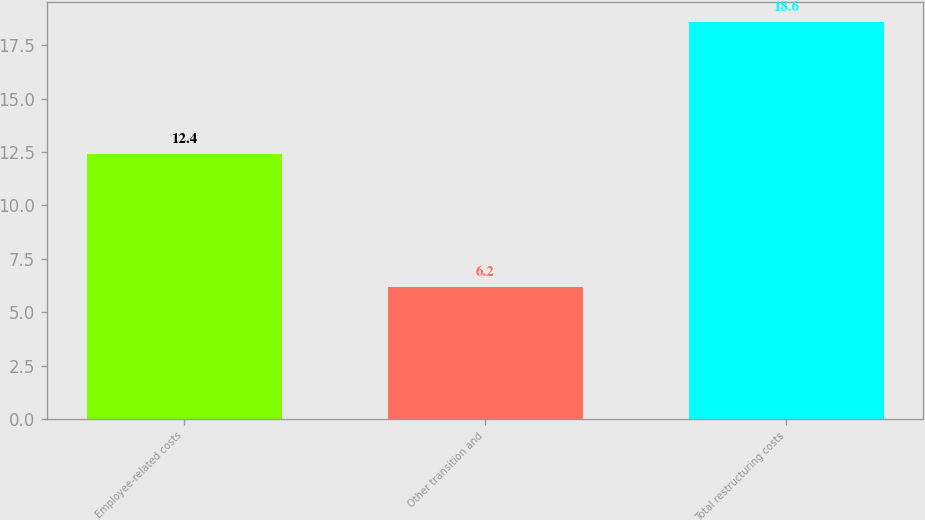<chart> <loc_0><loc_0><loc_500><loc_500><bar_chart><fcel>Employee-related costs<fcel>Other transition and<fcel>Total restructuring costs<nl><fcel>12.4<fcel>6.2<fcel>18.6<nl></chart> 